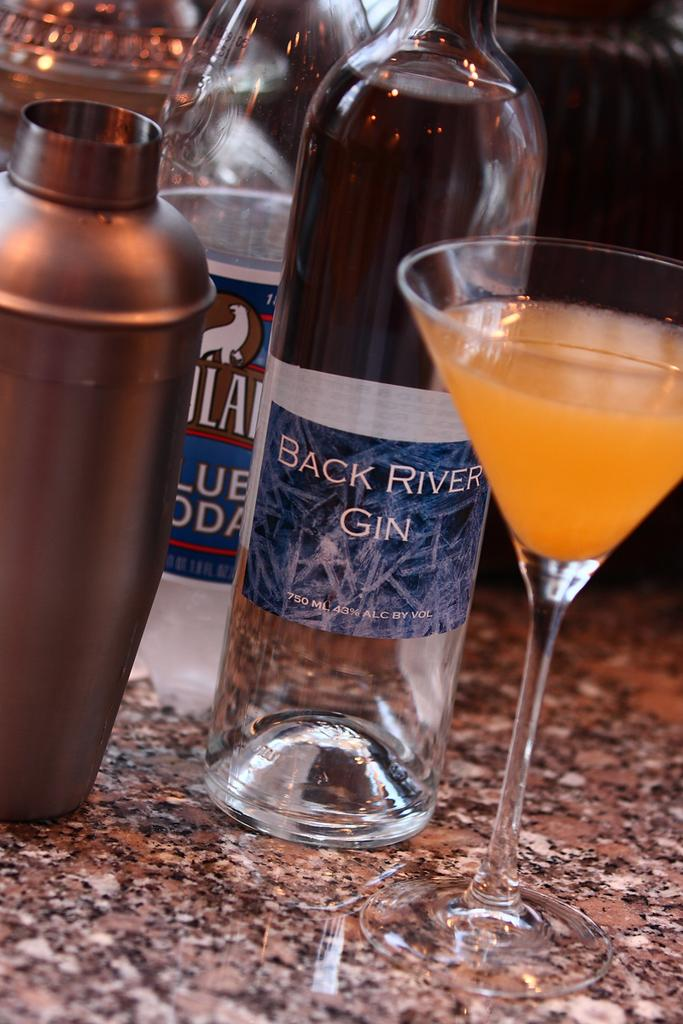Provide a one-sentence caption for the provided image. Bottle of Back River Gin next to a cup of alcohol. 